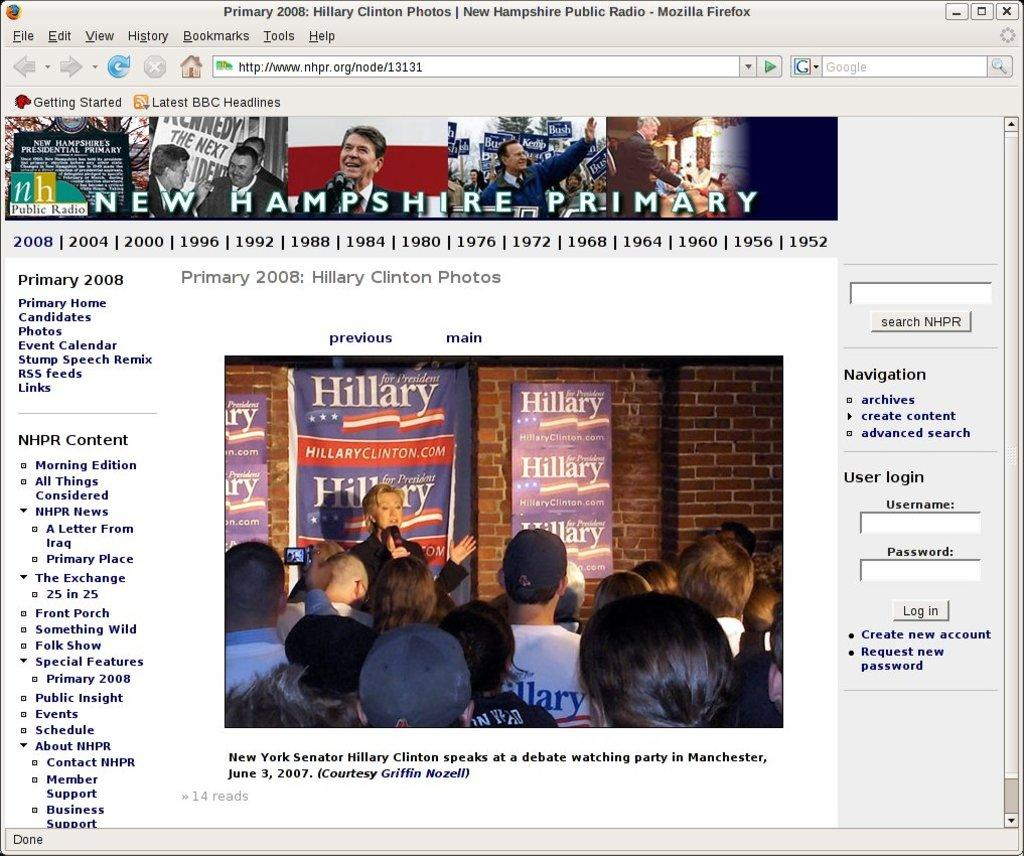What type of content is displayed in the image? The image is of a web page. What can be seen on the web page? There are people depicted on the web page. What else is present on the web page besides the people? There is information present on the web page. What type of baseball equipment can be seen in the image? There is no baseball equipment present in the image; it is a web page with people and information. How does the idea in the image appear to be quiet? The image is of a web page, and there is no reference to an idea being quiet. 